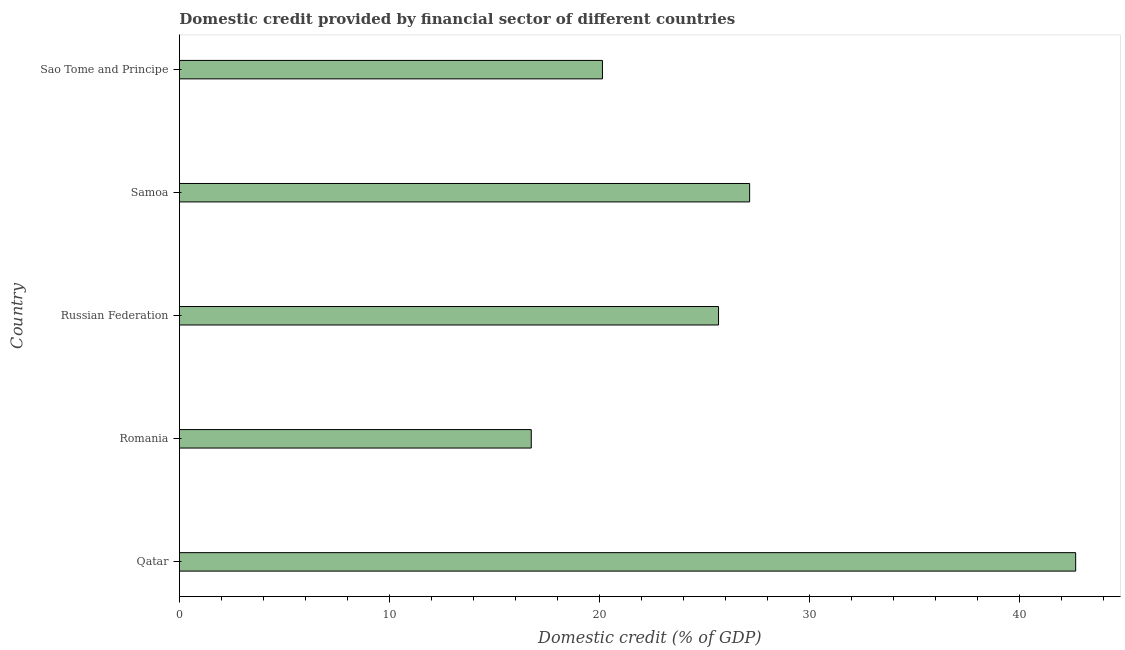Does the graph contain any zero values?
Provide a short and direct response. No. What is the title of the graph?
Offer a terse response. Domestic credit provided by financial sector of different countries. What is the label or title of the X-axis?
Keep it short and to the point. Domestic credit (% of GDP). What is the domestic credit provided by financial sector in Russian Federation?
Your answer should be compact. 25.66. Across all countries, what is the maximum domestic credit provided by financial sector?
Offer a terse response. 42.65. Across all countries, what is the minimum domestic credit provided by financial sector?
Make the answer very short. 16.74. In which country was the domestic credit provided by financial sector maximum?
Give a very brief answer. Qatar. In which country was the domestic credit provided by financial sector minimum?
Make the answer very short. Romania. What is the sum of the domestic credit provided by financial sector?
Provide a succinct answer. 132.33. What is the difference between the domestic credit provided by financial sector in Samoa and Sao Tome and Principe?
Give a very brief answer. 7. What is the average domestic credit provided by financial sector per country?
Your response must be concise. 26.46. What is the median domestic credit provided by financial sector?
Offer a terse response. 25.66. In how many countries, is the domestic credit provided by financial sector greater than 24 %?
Provide a succinct answer. 3. What is the ratio of the domestic credit provided by financial sector in Qatar to that in Romania?
Make the answer very short. 2.55. Is the difference between the domestic credit provided by financial sector in Romania and Samoa greater than the difference between any two countries?
Offer a terse response. No. What is the difference between the highest and the second highest domestic credit provided by financial sector?
Give a very brief answer. 15.52. What is the difference between the highest and the lowest domestic credit provided by financial sector?
Give a very brief answer. 25.91. How many bars are there?
Your response must be concise. 5. Are all the bars in the graph horizontal?
Give a very brief answer. Yes. Are the values on the major ticks of X-axis written in scientific E-notation?
Provide a short and direct response. No. What is the Domestic credit (% of GDP) of Qatar?
Your answer should be very brief. 42.65. What is the Domestic credit (% of GDP) of Romania?
Offer a very short reply. 16.74. What is the Domestic credit (% of GDP) in Russian Federation?
Your answer should be very brief. 25.66. What is the Domestic credit (% of GDP) in Samoa?
Your response must be concise. 27.14. What is the Domestic credit (% of GDP) of Sao Tome and Principe?
Ensure brevity in your answer.  20.13. What is the difference between the Domestic credit (% of GDP) in Qatar and Romania?
Keep it short and to the point. 25.91. What is the difference between the Domestic credit (% of GDP) in Qatar and Russian Federation?
Ensure brevity in your answer.  17. What is the difference between the Domestic credit (% of GDP) in Qatar and Samoa?
Your answer should be compact. 15.52. What is the difference between the Domestic credit (% of GDP) in Qatar and Sao Tome and Principe?
Provide a succinct answer. 22.52. What is the difference between the Domestic credit (% of GDP) in Romania and Russian Federation?
Your answer should be very brief. -8.91. What is the difference between the Domestic credit (% of GDP) in Romania and Samoa?
Make the answer very short. -10.39. What is the difference between the Domestic credit (% of GDP) in Romania and Sao Tome and Principe?
Your answer should be compact. -3.39. What is the difference between the Domestic credit (% of GDP) in Russian Federation and Samoa?
Give a very brief answer. -1.48. What is the difference between the Domestic credit (% of GDP) in Russian Federation and Sao Tome and Principe?
Your answer should be compact. 5.52. What is the difference between the Domestic credit (% of GDP) in Samoa and Sao Tome and Principe?
Keep it short and to the point. 7. What is the ratio of the Domestic credit (% of GDP) in Qatar to that in Romania?
Provide a short and direct response. 2.55. What is the ratio of the Domestic credit (% of GDP) in Qatar to that in Russian Federation?
Provide a succinct answer. 1.66. What is the ratio of the Domestic credit (% of GDP) in Qatar to that in Samoa?
Offer a very short reply. 1.57. What is the ratio of the Domestic credit (% of GDP) in Qatar to that in Sao Tome and Principe?
Offer a very short reply. 2.12. What is the ratio of the Domestic credit (% of GDP) in Romania to that in Russian Federation?
Your answer should be compact. 0.65. What is the ratio of the Domestic credit (% of GDP) in Romania to that in Samoa?
Offer a very short reply. 0.62. What is the ratio of the Domestic credit (% of GDP) in Romania to that in Sao Tome and Principe?
Offer a very short reply. 0.83. What is the ratio of the Domestic credit (% of GDP) in Russian Federation to that in Samoa?
Provide a succinct answer. 0.94. What is the ratio of the Domestic credit (% of GDP) in Russian Federation to that in Sao Tome and Principe?
Keep it short and to the point. 1.27. What is the ratio of the Domestic credit (% of GDP) in Samoa to that in Sao Tome and Principe?
Provide a succinct answer. 1.35. 